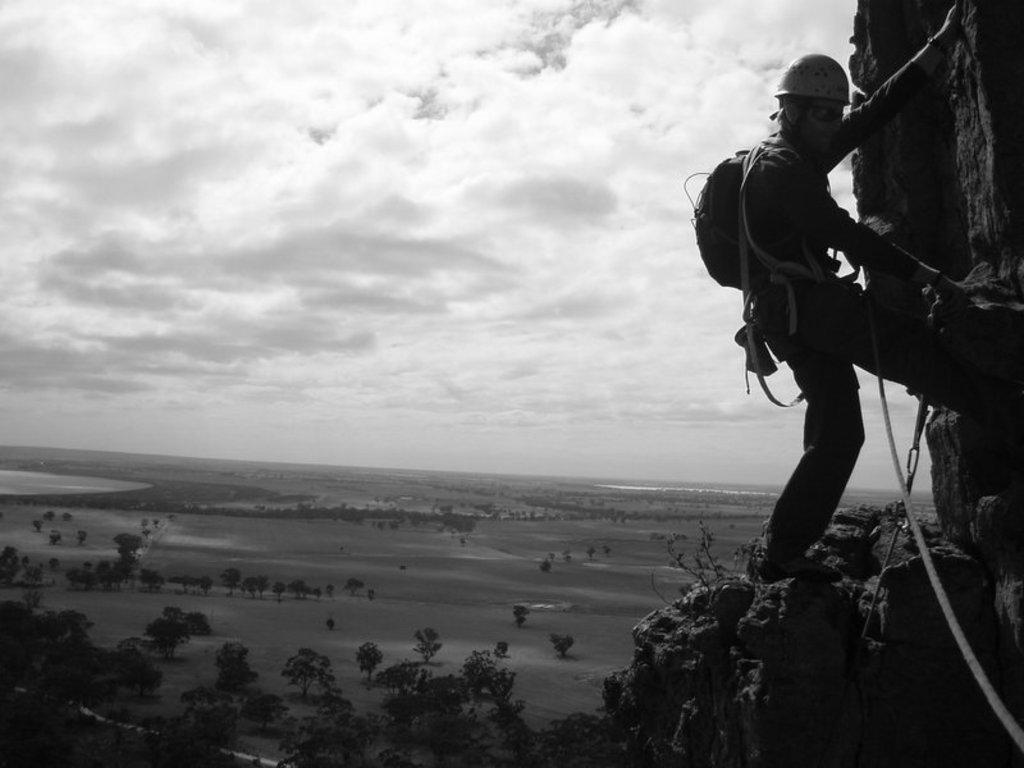Describe this image in one or two sentences. In the foreground I can see a person is climbing a mountain, bag and ropes. In the background I can see trees, water and the sky. This image is taken may be near the mountain. 